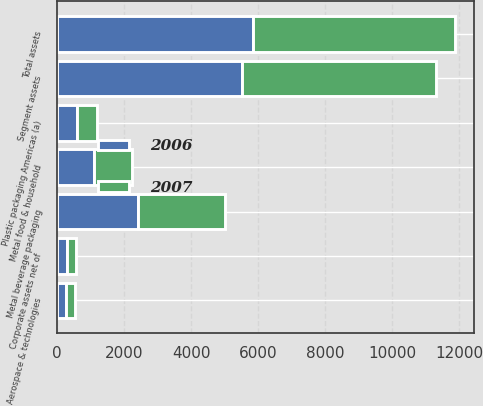<chart> <loc_0><loc_0><loc_500><loc_500><stacked_bar_chart><ecel><fcel>Metal beverage packaging<fcel>Metal food & household<fcel>Plastic packaging Americas (a)<fcel>Aerospace & technologies<fcel>Segment assets<fcel>Corporate assets net of<fcel>Total assets<nl><fcel>2007<fcel>2600.5<fcel>1141.7<fcel>568.8<fcel>278.7<fcel>5759.3<fcel>261.3<fcel>6020.6<nl><fcel>2006<fcel>2412.7<fcel>1094.9<fcel>609<fcel>268.2<fcel>5532<fcel>308.9<fcel>5840.9<nl></chart> 